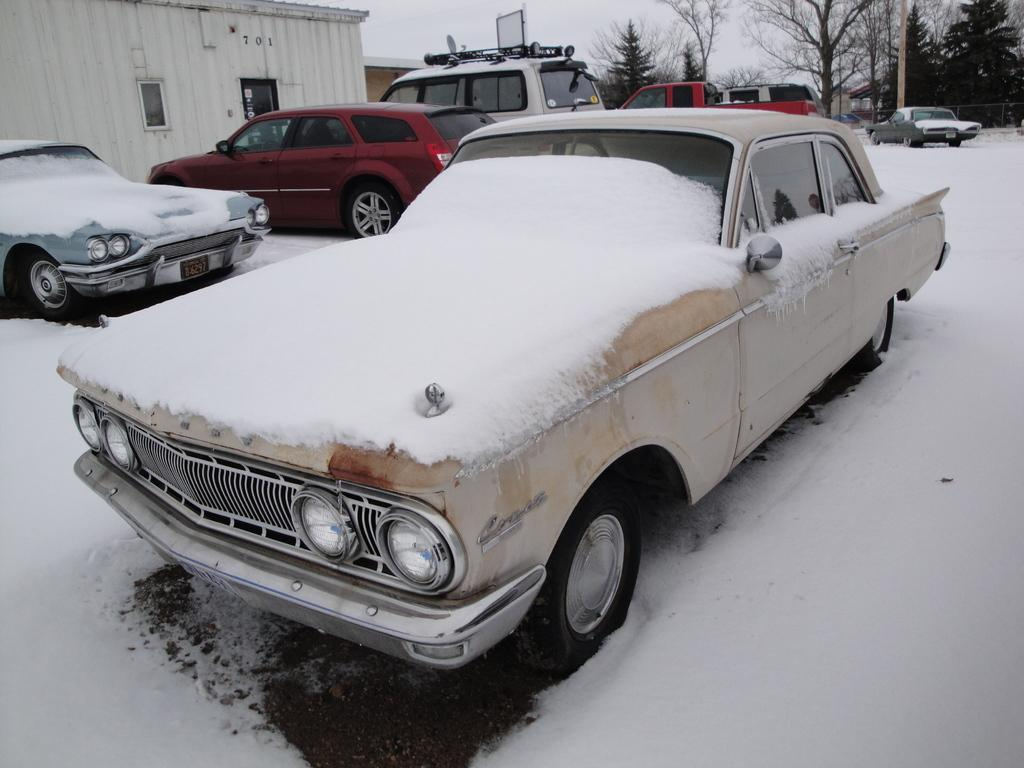What is happening on the road in the image? There are vehicles on the road in the image. What is the weather like in the image? There is snow visible in the image, indicating a snowy or wintry scene. What can be seen in the background of the image? There are buildings, trees, and the sky visible in the background of the image. What type of agreement is being signed in the image? There is no indication of an agreement or any signing activity in the image. Can you see any popcorn in the image? There is no popcorn present in the image. 